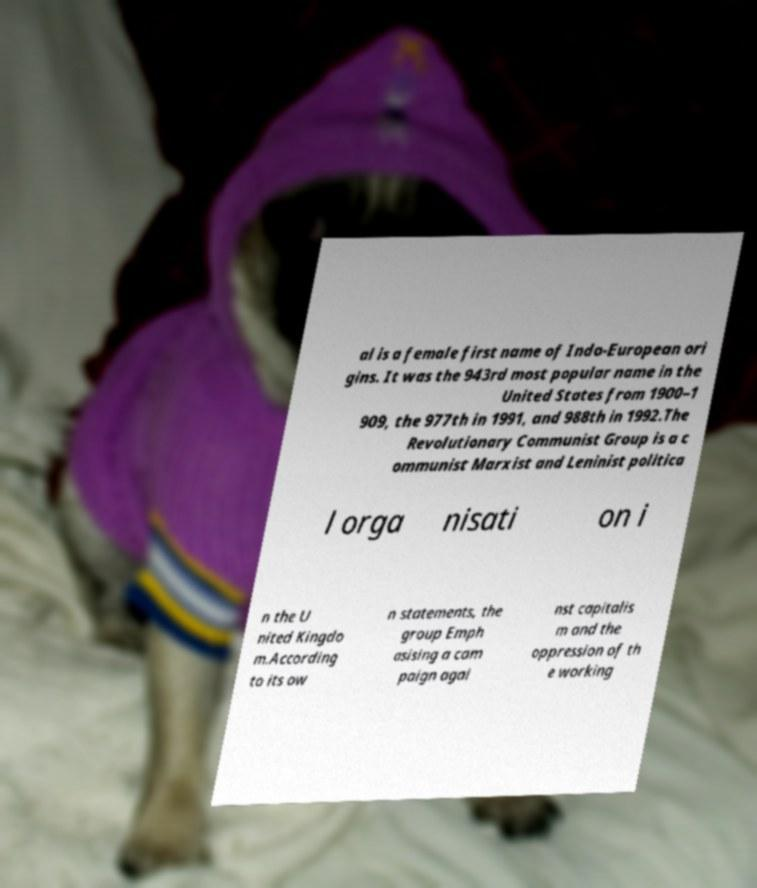Can you accurately transcribe the text from the provided image for me? al is a female first name of Indo-European ori gins. It was the 943rd most popular name in the United States from 1900–1 909, the 977th in 1991, and 988th in 1992.The Revolutionary Communist Group is a c ommunist Marxist and Leninist politica l orga nisati on i n the U nited Kingdo m.According to its ow n statements, the group Emph asising a cam paign agai nst capitalis m and the oppression of th e working 